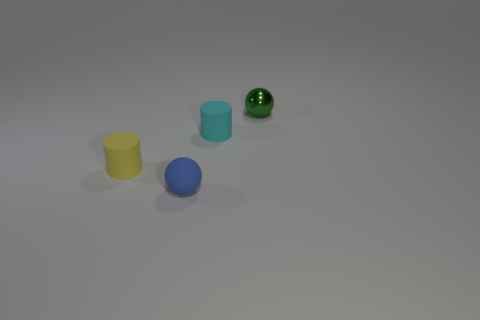Is there any other thing that is the same material as the green object?
Your response must be concise. No. What number of big objects are either yellow matte cylinders or green balls?
Keep it short and to the point. 0. The blue matte ball has what size?
Your response must be concise. Small. Is the size of the cyan cylinder the same as the rubber cylinder to the left of the cyan rubber cylinder?
Your answer should be very brief. Yes. What number of cyan objects are either rubber spheres or big cubes?
Provide a succinct answer. 0. What number of green metallic spheres are there?
Your response must be concise. 1. What is the size of the ball in front of the small cyan cylinder?
Keep it short and to the point. Small. Does the metal sphere have the same size as the yellow object?
Make the answer very short. Yes. How many things are big blocks or things in front of the small green metallic thing?
Make the answer very short. 3. What is the green sphere made of?
Keep it short and to the point. Metal. 